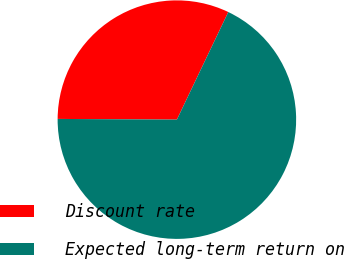<chart> <loc_0><loc_0><loc_500><loc_500><pie_chart><fcel>Discount rate<fcel>Expected long-term return on<nl><fcel>32.0%<fcel>68.0%<nl></chart> 